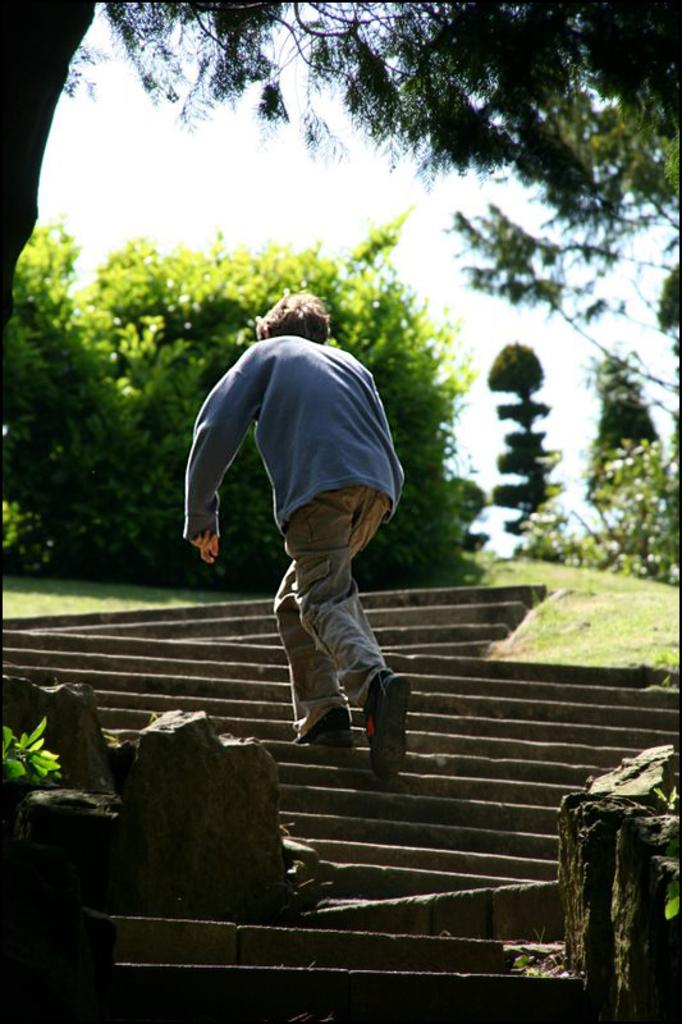What is the person in the image doing? There is a person climbing the stairs in the image. What can be seen in the background of the image? There are trees visible in the background of the image. What is present on the left side of the image? There are rocks on the left side of the image. What is present on the right side of the image? There are rocks on the right side of the image. What type of beam is the person using to climb the stairs in the image? There is no beam present in the image; the person is climbing regular stairs. 